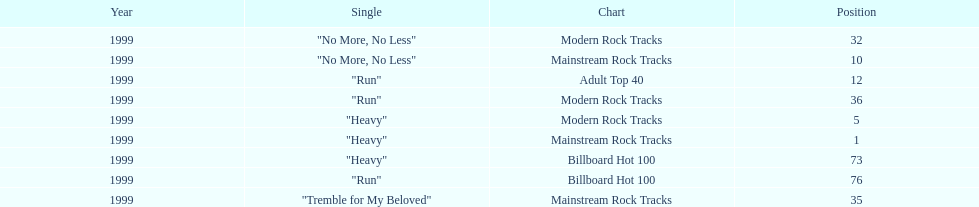How many different charts did "run" make? 3. 